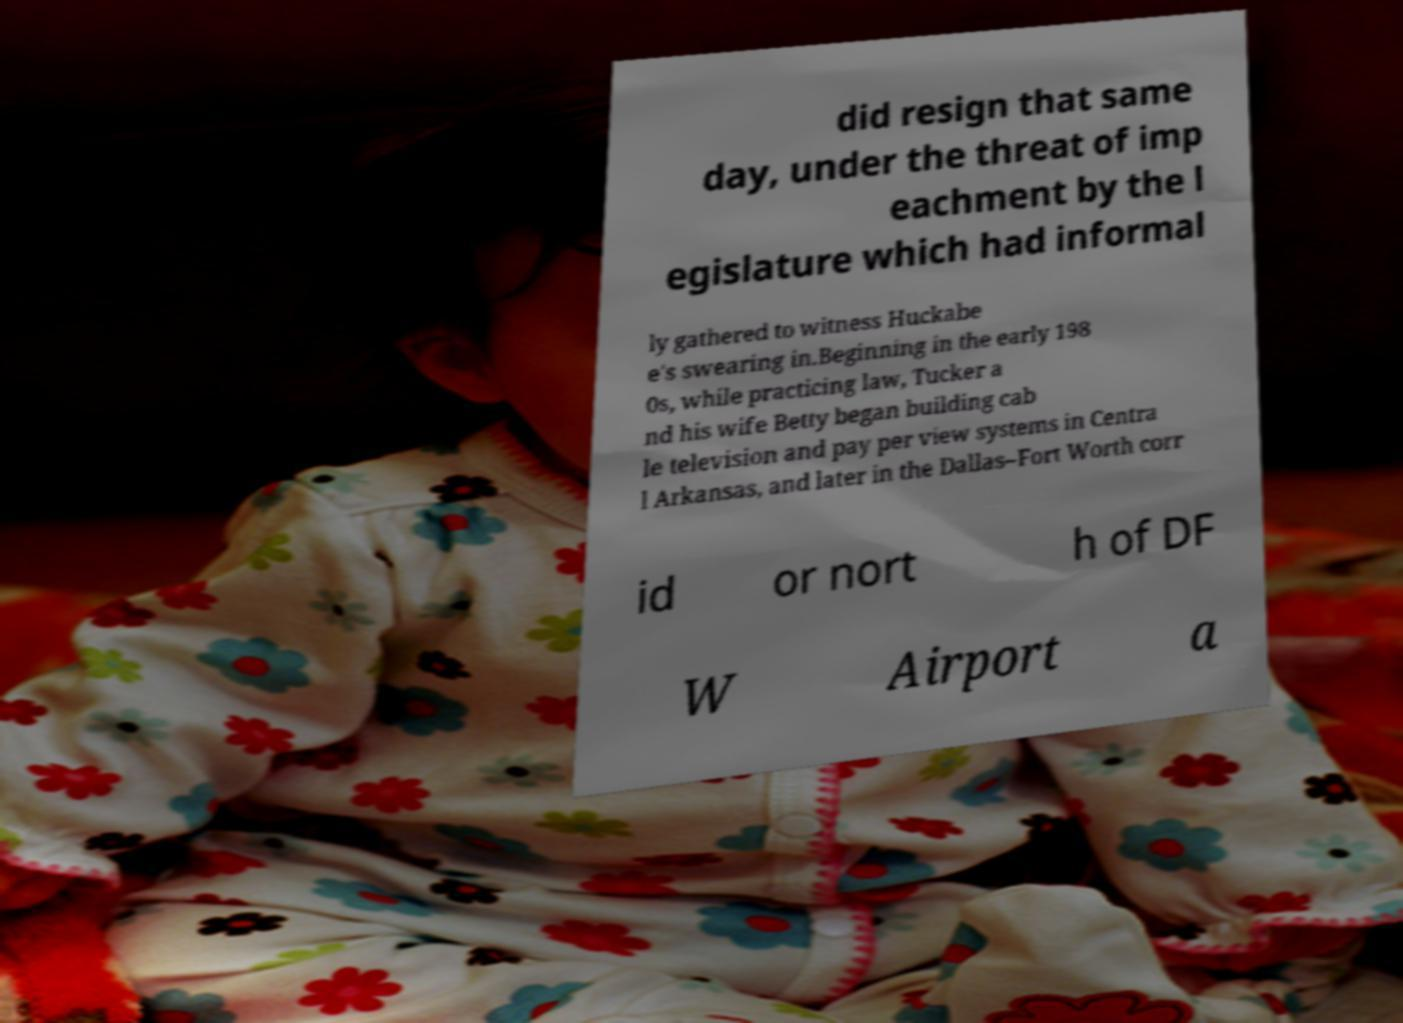I need the written content from this picture converted into text. Can you do that? did resign that same day, under the threat of imp eachment by the l egislature which had informal ly gathered to witness Huckabe e's swearing in.Beginning in the early 198 0s, while practicing law, Tucker a nd his wife Betty began building cab le television and pay per view systems in Centra l Arkansas, and later in the Dallas–Fort Worth corr id or nort h of DF W Airport a 